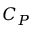<formula> <loc_0><loc_0><loc_500><loc_500>C _ { P }</formula> 